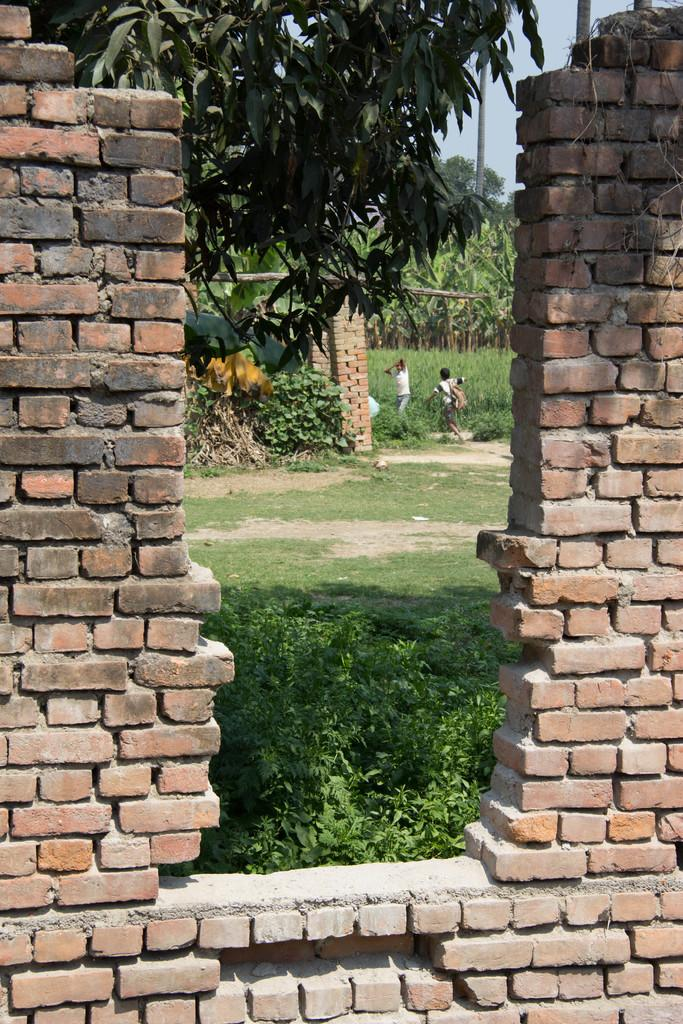What is present in the image that serves as a barrier or divider? There is a wall in the image. Can you describe the people in the background of the image? There are two persons in the background of the image. What type of natural environment is visible in the background of the image? There is grass and trees visible in the background of the image. What color is the gold object in the image? There is no gold object present in the image. How many persons are in the background of the image, considering the fifth person? There are only two persons visible in the background of the image, and there is no mention of a fifth person. 